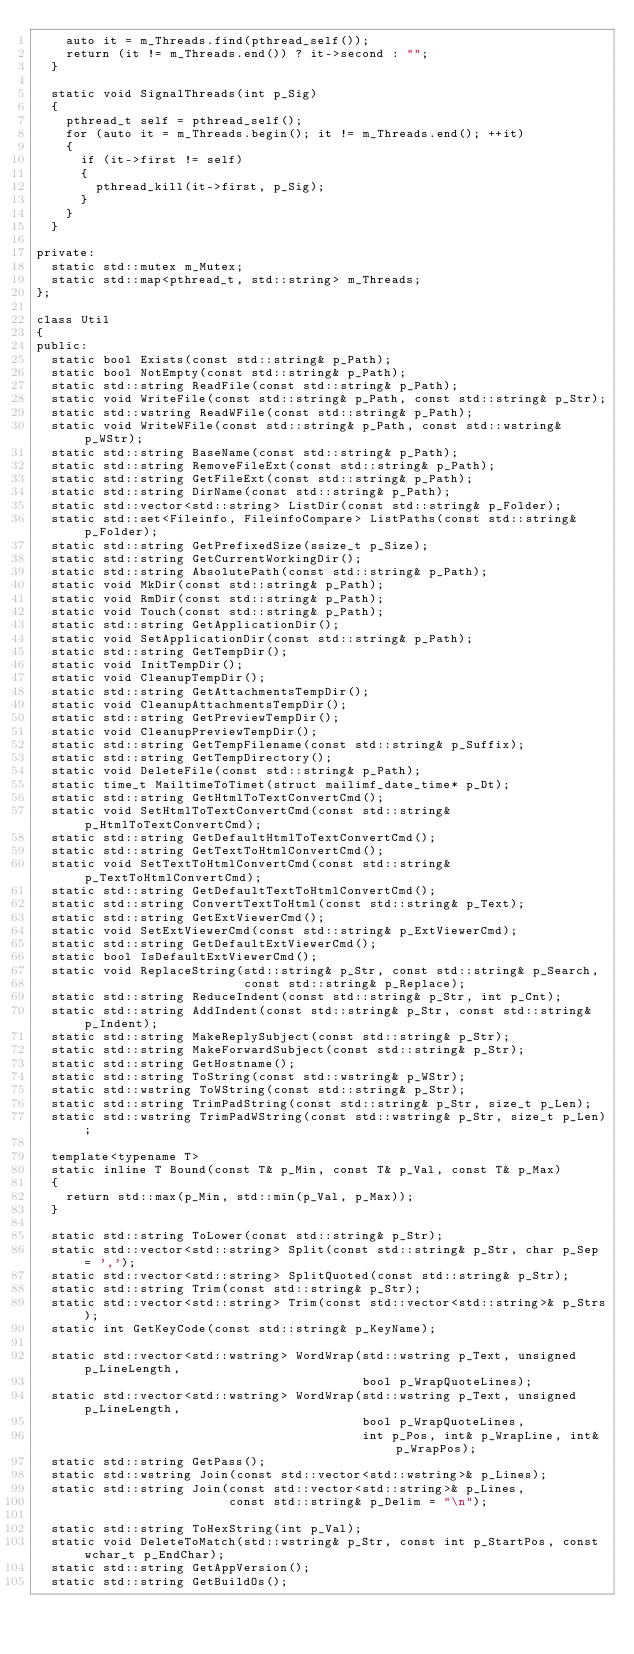Convert code to text. <code><loc_0><loc_0><loc_500><loc_500><_C_>    auto it = m_Threads.find(pthread_self());
    return (it != m_Threads.end()) ? it->second : "";
  }

  static void SignalThreads(int p_Sig)
  {
    pthread_t self = pthread_self();
    for (auto it = m_Threads.begin(); it != m_Threads.end(); ++it)
    {
      if (it->first != self)
      {
        pthread_kill(it->first, p_Sig);
      }
    }
  }

private:
  static std::mutex m_Mutex;
  static std::map<pthread_t, std::string> m_Threads;
};

class Util
{
public:
  static bool Exists(const std::string& p_Path);
  static bool NotEmpty(const std::string& p_Path);
  static std::string ReadFile(const std::string& p_Path);
  static void WriteFile(const std::string& p_Path, const std::string& p_Str);
  static std::wstring ReadWFile(const std::string& p_Path);
  static void WriteWFile(const std::string& p_Path, const std::wstring& p_WStr);
  static std::string BaseName(const std::string& p_Path);
  static std::string RemoveFileExt(const std::string& p_Path);
  static std::string GetFileExt(const std::string& p_Path);
  static std::string DirName(const std::string& p_Path);
  static std::vector<std::string> ListDir(const std::string& p_Folder);
  static std::set<Fileinfo, FileinfoCompare> ListPaths(const std::string& p_Folder);
  static std::string GetPrefixedSize(ssize_t p_Size);
  static std::string GetCurrentWorkingDir();
  static std::string AbsolutePath(const std::string& p_Path);
  static void MkDir(const std::string& p_Path);
  static void RmDir(const std::string& p_Path);
  static void Touch(const std::string& p_Path);
  static std::string GetApplicationDir();
  static void SetApplicationDir(const std::string& p_Path);
  static std::string GetTempDir();
  static void InitTempDir();
  static void CleanupTempDir();
  static std::string GetAttachmentsTempDir();
  static void CleanupAttachmentsTempDir();
  static std::string GetPreviewTempDir();
  static void CleanupPreviewTempDir();
  static std::string GetTempFilename(const std::string& p_Suffix);
  static std::string GetTempDirectory();
  static void DeleteFile(const std::string& p_Path);
  static time_t MailtimeToTimet(struct mailimf_date_time* p_Dt);
  static std::string GetHtmlToTextConvertCmd();
  static void SetHtmlToTextConvertCmd(const std::string& p_HtmlToTextConvertCmd);
  static std::string GetDefaultHtmlToTextConvertCmd();
  static std::string GetTextToHtmlConvertCmd();
  static void SetTextToHtmlConvertCmd(const std::string& p_TextToHtmlConvertCmd);
  static std::string GetDefaultTextToHtmlConvertCmd();
  static std::string ConvertTextToHtml(const std::string& p_Text);
  static std::string GetExtViewerCmd();
  static void SetExtViewerCmd(const std::string& p_ExtViewerCmd);
  static std::string GetDefaultExtViewerCmd();
  static bool IsDefaultExtViewerCmd();
  static void ReplaceString(std::string& p_Str, const std::string& p_Search,
                            const std::string& p_Replace);
  static std::string ReduceIndent(const std::string& p_Str, int p_Cnt);
  static std::string AddIndent(const std::string& p_Str, const std::string& p_Indent);
  static std::string MakeReplySubject(const std::string& p_Str);
  static std::string MakeForwardSubject(const std::string& p_Str);
  static std::string GetHostname();
  static std::string ToString(const std::wstring& p_WStr);
  static std::wstring ToWString(const std::string& p_Str);
  static std::string TrimPadString(const std::string& p_Str, size_t p_Len);
  static std::wstring TrimPadWString(const std::wstring& p_Str, size_t p_Len);

  template<typename T>
  static inline T Bound(const T& p_Min, const T& p_Val, const T& p_Max)
  {
    return std::max(p_Min, std::min(p_Val, p_Max));
  }

  static std::string ToLower(const std::string& p_Str);
  static std::vector<std::string> Split(const std::string& p_Str, char p_Sep = ',');
  static std::vector<std::string> SplitQuoted(const std::string& p_Str);
  static std::string Trim(const std::string& p_Str);
  static std::vector<std::string> Trim(const std::vector<std::string>& p_Strs);
  static int GetKeyCode(const std::string& p_KeyName);

  static std::vector<std::wstring> WordWrap(std::wstring p_Text, unsigned p_LineLength,
                                            bool p_WrapQuoteLines);
  static std::vector<std::wstring> WordWrap(std::wstring p_Text, unsigned p_LineLength,
                                            bool p_WrapQuoteLines,
                                            int p_Pos, int& p_WrapLine, int& p_WrapPos);
  static std::string GetPass();
  static std::wstring Join(const std::vector<std::wstring>& p_Lines);
  static std::string Join(const std::vector<std::string>& p_Lines,
                          const std::string& p_Delim = "\n");

  static std::string ToHexString(int p_Val);
  static void DeleteToMatch(std::wstring& p_Str, const int p_StartPos, const wchar_t p_EndChar);
  static std::string GetAppVersion();
  static std::string GetBuildOs();</code> 